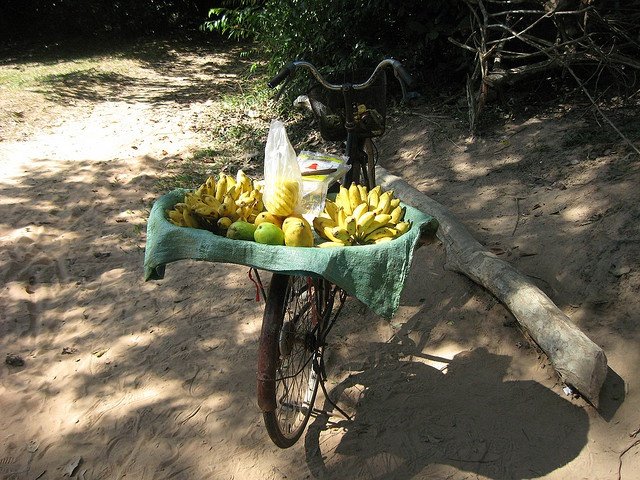Describe the objects in this image and their specific colors. I can see bicycle in black, gray, and maroon tones, banana in black, khaki, and olive tones, banana in black, olive, and gray tones, banana in black and olive tones, and banana in black and olive tones in this image. 